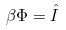<formula> <loc_0><loc_0><loc_500><loc_500>\beta \Phi = \hat { I }</formula> 